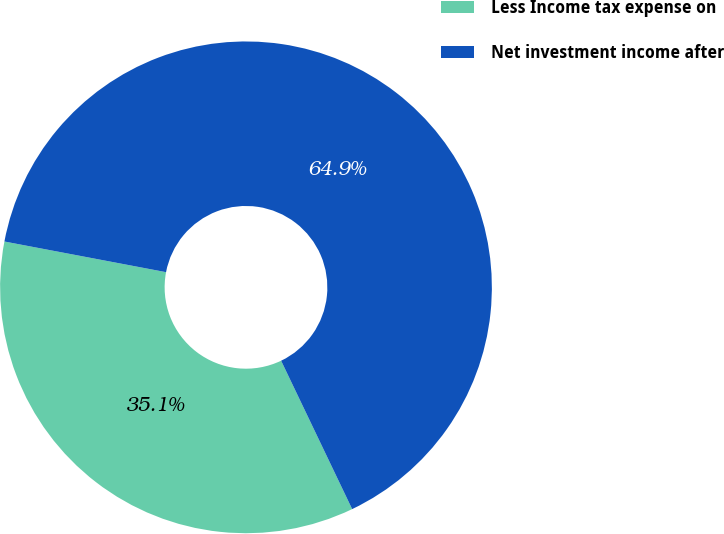Convert chart. <chart><loc_0><loc_0><loc_500><loc_500><pie_chart><fcel>Less Income tax expense on<fcel>Net investment income after<nl><fcel>35.09%<fcel>64.91%<nl></chart> 